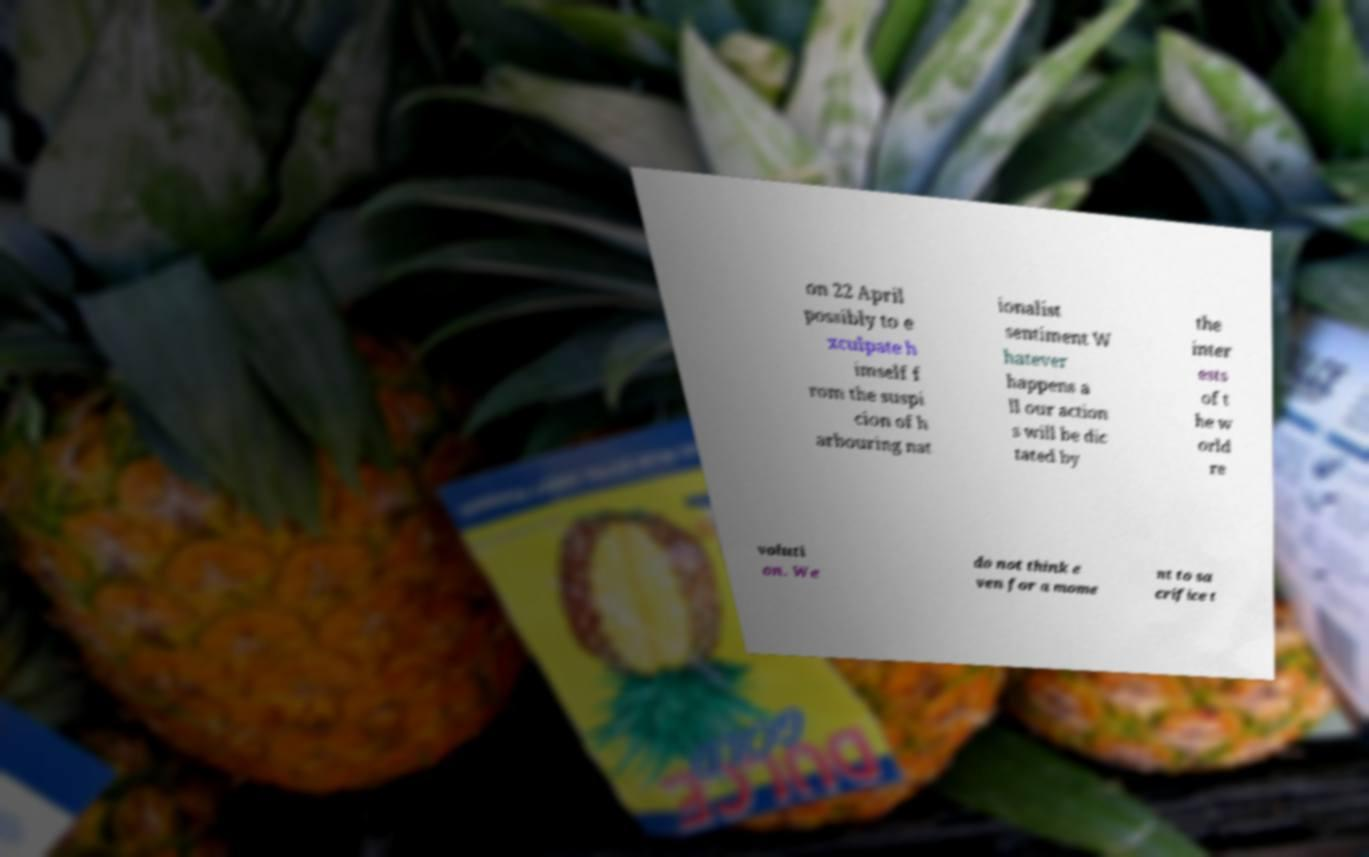Please read and relay the text visible in this image. What does it say? on 22 April possibly to e xculpate h imself f rom the suspi cion of h arbouring nat ionalist sentiment W hatever happens a ll our action s will be dic tated by the inter ests of t he w orld re voluti on. We do not think e ven for a mome nt to sa crifice t 